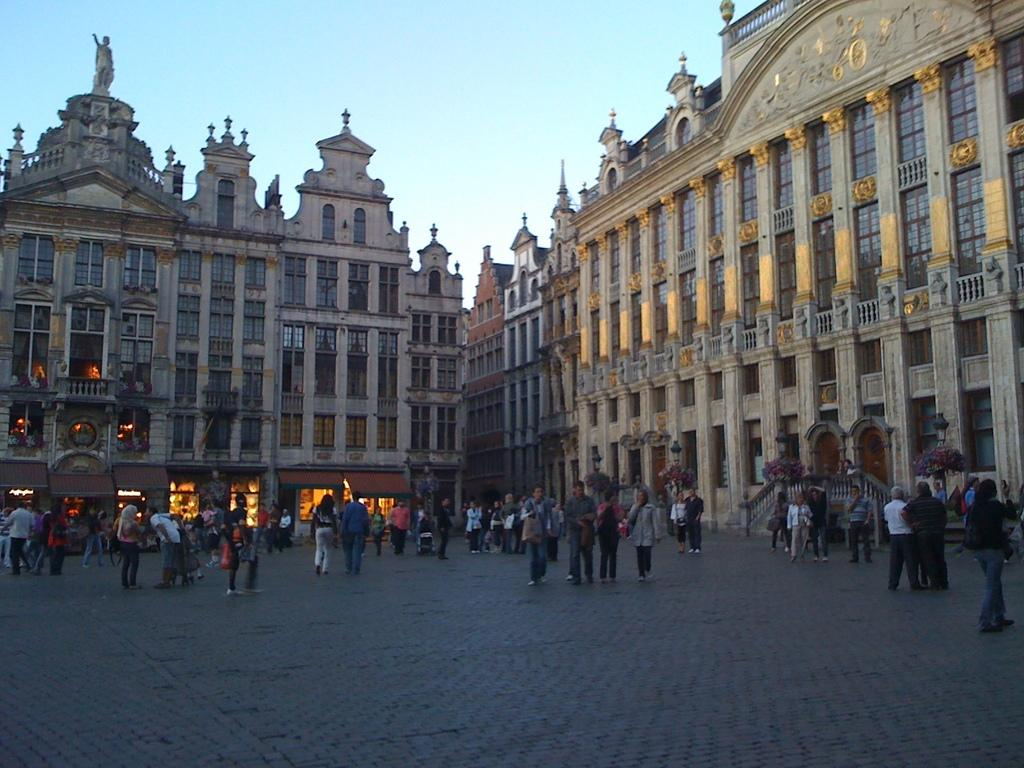What is happening in the image? There are persons standing in the image. What can be seen in the distance behind the persons? There are buildings in the background of the image. What type of scarecrow is standing next to the persons in the image? There is no scarecrow present in the image; only persons and buildings are visible. What is the texture of the tongue of the person in the image? The image does not provide information about the texture of anyone's tongue, as it focuses on the persons standing and the buildings in the background. 